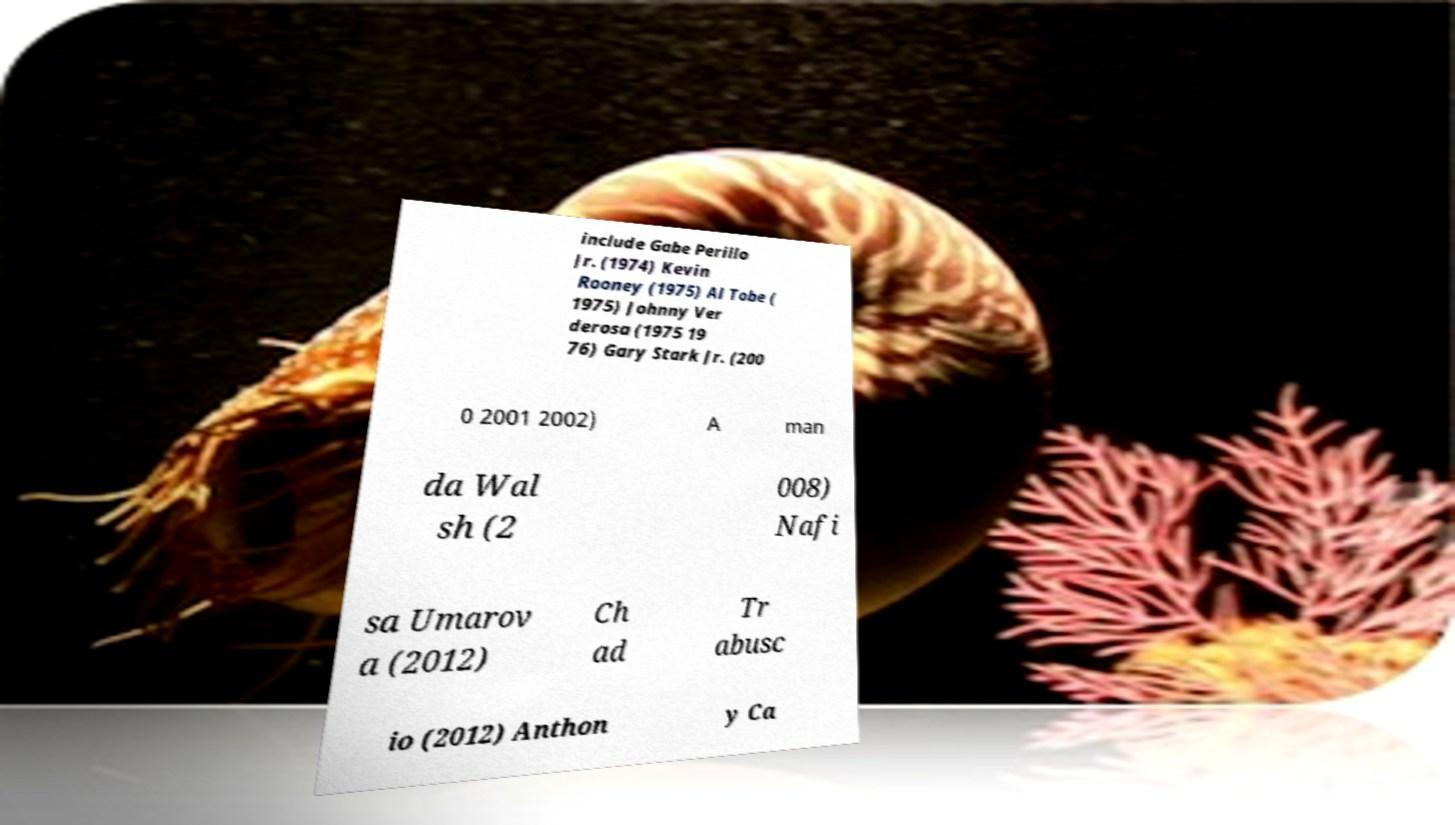Please identify and transcribe the text found in this image. include Gabe Perillo Jr. (1974) Kevin Rooney (1975) Al Tobe ( 1975) Johnny Ver derosa (1975 19 76) Gary Stark Jr. (200 0 2001 2002) A man da Wal sh (2 008) Nafi sa Umarov a (2012) Ch ad Tr abusc io (2012) Anthon y Ca 